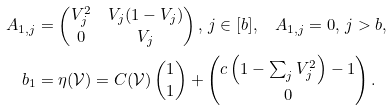<formula> <loc_0><loc_0><loc_500><loc_500>A _ { 1 , j } & = \begin{pmatrix} V _ { j } ^ { 2 } & V _ { j } ( 1 - V _ { j } ) \\ 0 & V _ { j } \end{pmatrix} , \, j \in [ b ] , \quad A _ { 1 , j } = { 0 } , \, j > b , \\ b _ { 1 } & = \eta ( \mathcal { V } ) = C ( \mathcal { V } ) \begin{pmatrix} 1 \\ 1 \end{pmatrix} + \begin{pmatrix} c \left ( 1 - \sum _ { j } V _ { j } ^ { 2 } \right ) - 1 \\ 0 \end{pmatrix} .</formula> 